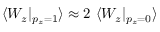Convert formula to latex. <formula><loc_0><loc_0><loc_500><loc_500>\langle W _ { z } | _ { p _ { z } { = } 1 } \rangle \approx 2 \langle W _ { z } | _ { p _ { z } { = } 0 } \rangle</formula> 